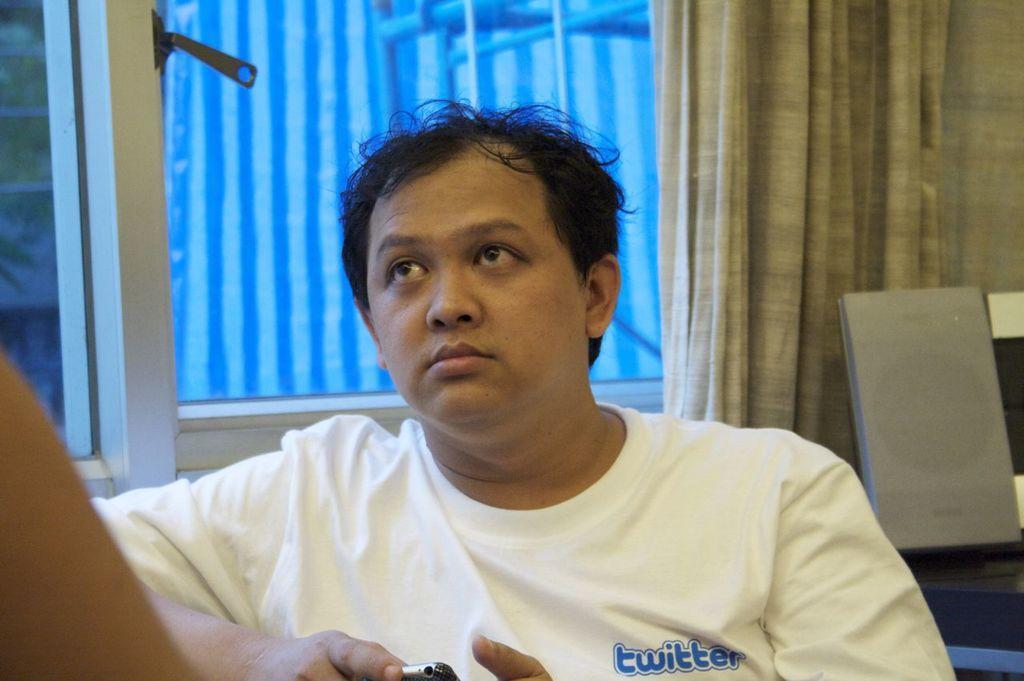Who is the main subject in the foreground of the image? There is a man in the foreground of the image. What is the man wearing? The man is wearing a white T-shirt. What is the man holding in the image? The man is holding a mobile. What can be seen in the background of the image? There is a window, a curtain, and objects visible in the background. What is the purpose of the curtain in the image? The curtain is associated with the window, possibly for privacy or decoration. Can you describe the hand on the left side of the image? There is a hand on the left side of the image, but it is not clear what it is doing or who it belongs to. What type of park is visible in the image? There is no park visible in the image. What is the end result of the man's actions in the image? The image does not show the man performing any actions, so it is impossible to determine an end result. 